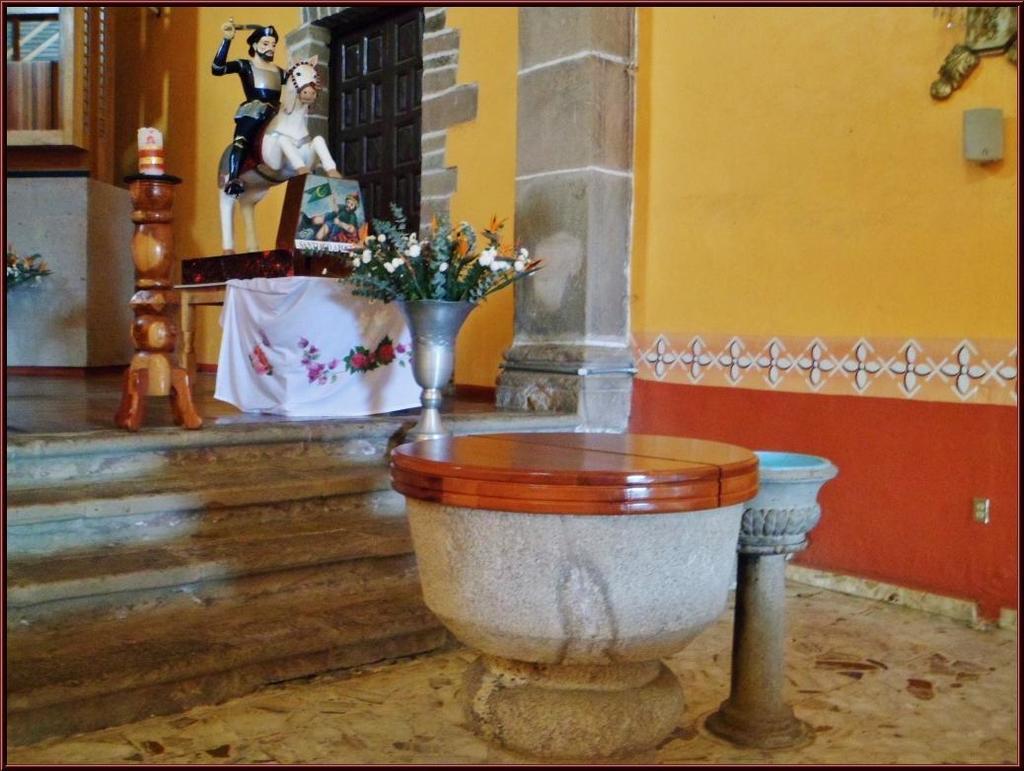How would you summarize this image in a sentence or two? In this image I can see flower pot on a round table. Here I can see sculpture of a horse and a man and some other objects on the ground. I can also see a yellow color wall and a window. 